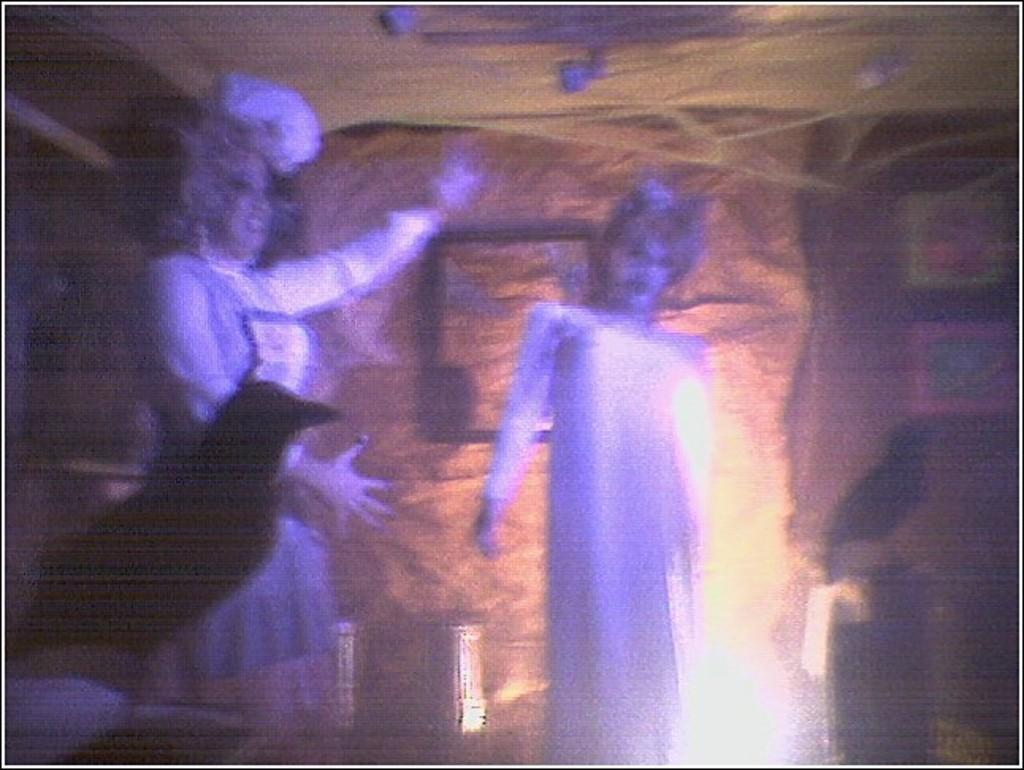How would you summarize this image in a sentence or two? In this picture we can see two persons in the middle, it looks like a bird in the front, we can see a blurry background. 